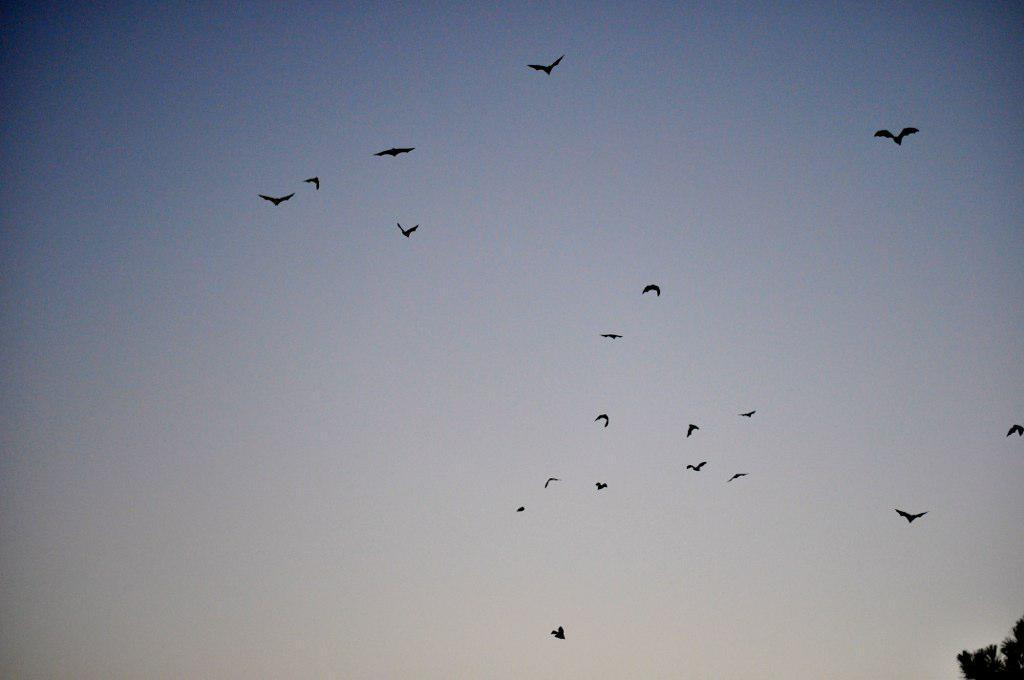What type of animals can be seen in the image? Birds can be seen in the image. What are the birds doing in the image? The birds are flying in the sky. What idea is being advertised by the clam in the image? There is no clam present in the image, and therefore no idea is being advertised. 